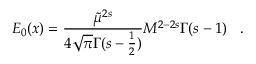Convert formula to latex. <formula><loc_0><loc_0><loc_500><loc_500>E _ { 0 } ( x ) = \frac { \tilde { \mu } ^ { 2 s } } { 4 \sqrt { \pi } \Gamma ( s - \frac { 1 } { 2 } ) } M ^ { 2 - 2 s } \Gamma ( s - 1 ) \, \ \ .</formula> 